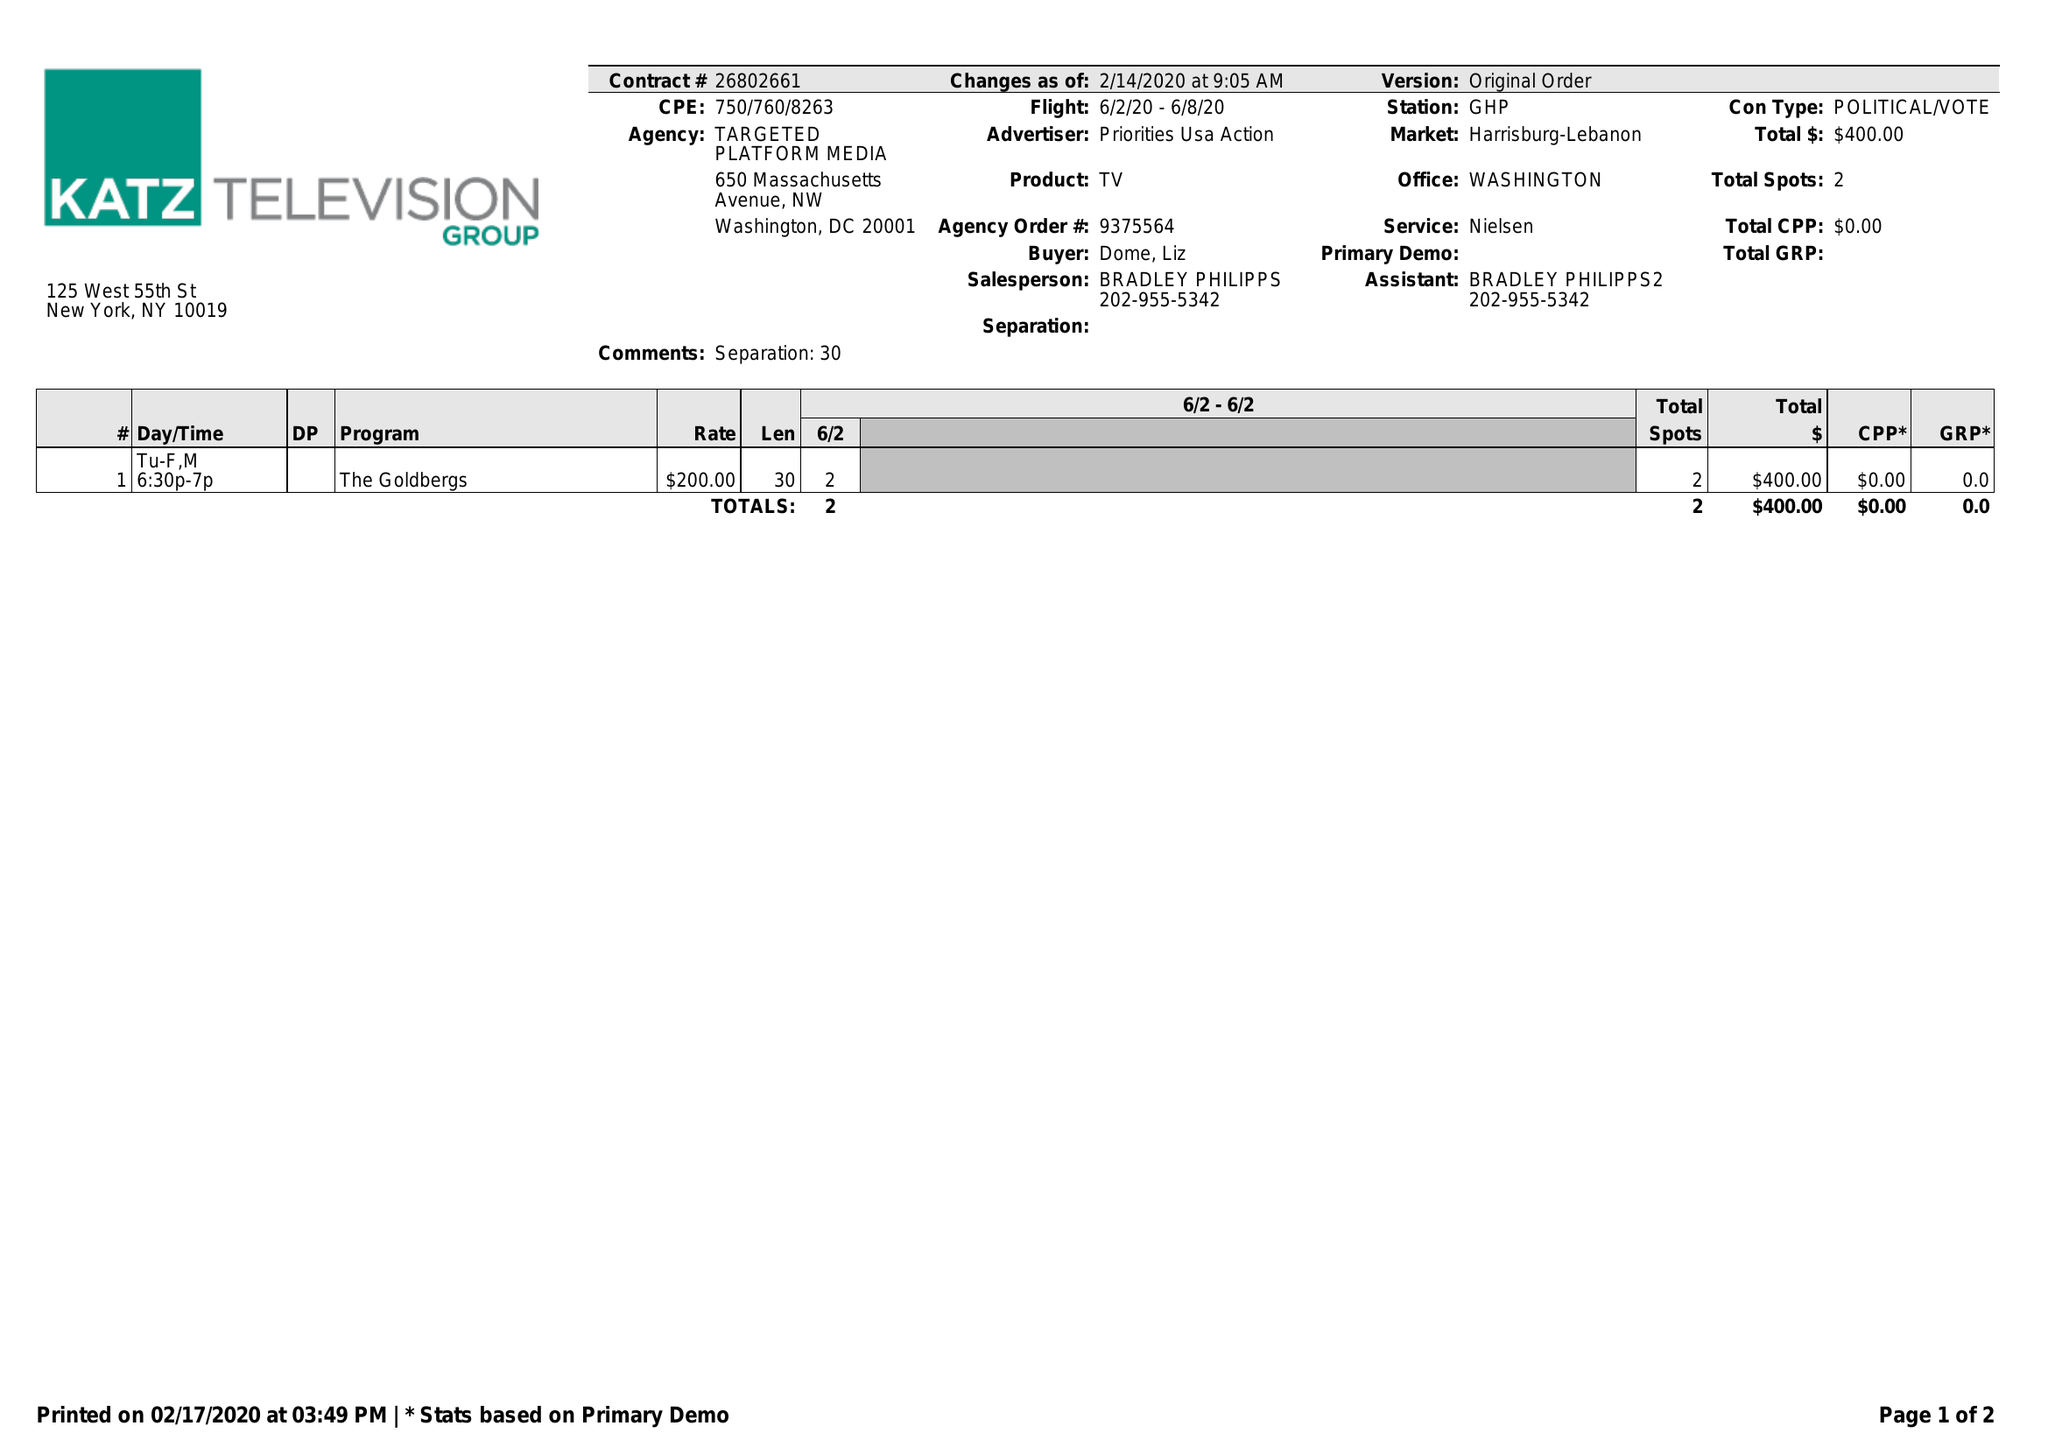What is the value for the gross_amount?
Answer the question using a single word or phrase. 400.00 